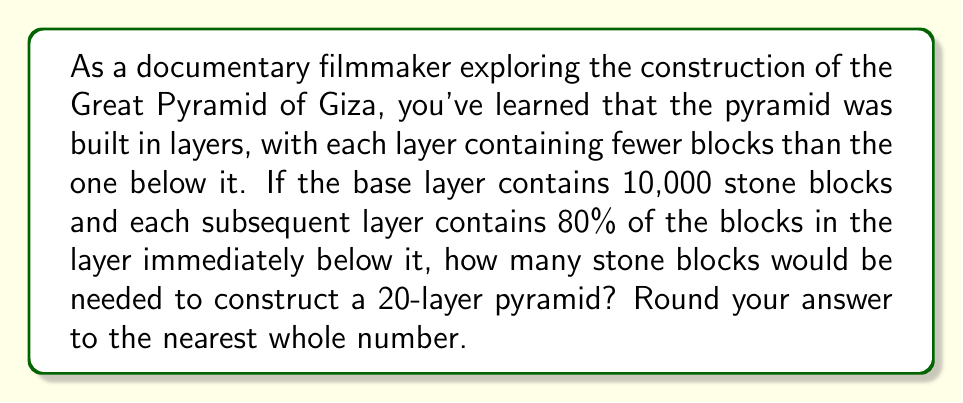Can you answer this question? Let's approach this step-by-step:

1) We can model this situation using exponential decay, where each layer has 80% of the blocks of the previous layer.

2) Let's define our variables:
   $a$ = number of blocks in the base layer (10,000)
   $r$ = ratio of blocks between consecutive layers (0.80)
   $n$ = number of layers (20)

3) The number of blocks in each layer can be represented as:
   Layer 1 (base): $a = 10000$
   Layer 2: $ar = 10000 * 0.80 = 8000$
   Layer 3: $ar^2 = 10000 * 0.80^2 = 6400$
   ...
   Layer 20: $ar^{19} = 10000 * 0.80^{19}$

4) To find the total number of blocks, we need to sum this geometric sequence:
   $S_n = a + ar + ar^2 + ... + ar^{n-1}$

5) The formula for the sum of a geometric sequence is:
   $S_n = a\frac{1-r^n}{1-r}$ where $r \neq 1$

6) Plugging in our values:
   $S_{20} = 10000\frac{1-0.80^{20}}{1-0.80}$

7) Let's calculate this:
   $S_{20} = 10000\frac{1-0.0115}{0.20} = 10000 * 4.9425 = 49425$

8) Rounding to the nearest whole number: 49,425
Answer: 49,425 blocks 